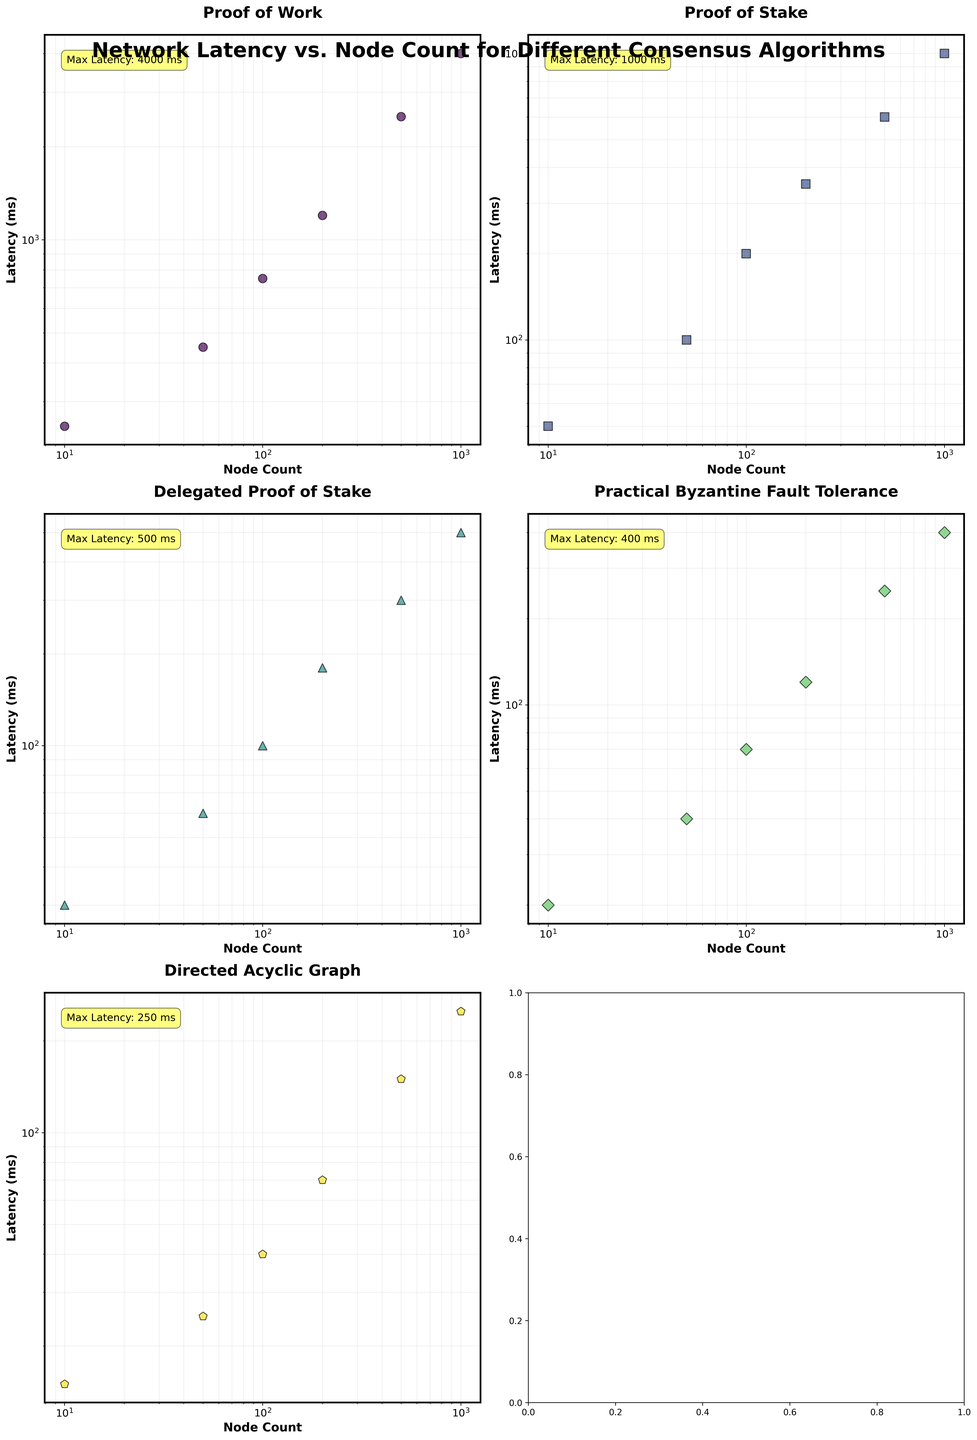What is the consensus algorithm with the lowest latency for 1000 nodes? To determine the consensus algorithm with the lowest latency for 1000 nodes, look at the scatter plots and identify the latency value for 1000 nodes across all algorithms. The one with the smallest value is the answer. The values are: Proof of Work (4000 ms), Proof of Stake (1000 ms), Delegated Proof of Stake (500 ms), Practical Byzantine Fault Tolerance (400 ms), Directed Acyclic Graph (250 ms).
Answer: Directed Acyclic Graph Which consensus algorithm shows the highest increase in latency as the node count goes from 10 to 100? To find the highest increase, calculate the difference in latency between 10 nodes and 100 nodes for each algorithm. The differences are: Proof of Work (750 - 250 = 500 ms), Proof of Stake (200 - 50 = 150 ms), Delegated Proof of Stake (100 - 30 = 70 ms), Practical Byzantine Fault Tolerance (70 - 20 = 50 ms), Directed Acyclic Graph (40 - 15 = 25 ms).
Answer: Proof of Work How does the latency of Proof of Stake compare to Delegated Proof of Stake for 500 nodes? Compare the latency values for Proof of Stake and Delegated Proof of Stake at 500 nodes. Proof of Stake has a latency of 600 ms and Delegated Proof of Stake has a latency of 300 ms.
Answer: Proof of Stake is higher What is the average latency for Practical Byzantine Fault Tolerance at 50 and 100 nodes? Calculate the average by adding the latency values at 50 and 100 nodes for Practical Byzantine Fault Tolerance and then dividing by 2: (40 + 70) / 2 = 55 ms.
Answer: 55 ms Which consensus algorithm has the steepest slope on a log-log scale for node count vs. latency? On a log-log scale, the steepest slope corresponds to the algorithm whose latency increases most rapidly with node count. By observation, Proof of Work's latency increases significantly faster compared to other algorithms, indicating a steeper slope.
Answer: Proof of Work For which consensus algorithm does the latency remain consistently below 1000 ms for all node counts? Identify the algorithms where all latency values remain below 1000 ms. The algorithms are: Delegated Proof of Stake, Practical Byzantine Fault Tolerance, and Directed Acyclic Graph.
Answer: Delegated Proof of Stake, Practical Byzantine Fault Tolerance, Directed Acyclic Graph Which algorithm achieves a latency of 250 ms at the fewest number of nodes? Identify the node count where each algorithm reaches 250 ms latency. Delegated Proof of Stake reaches 250 ms at 1000 nodes, Practical Byzantine Fault Tolerance at 500 nodes, Directed Acyclic Graph at 500 nodes.
Answer: Practical Byzantine Fault Tolerance at 500 nodes 